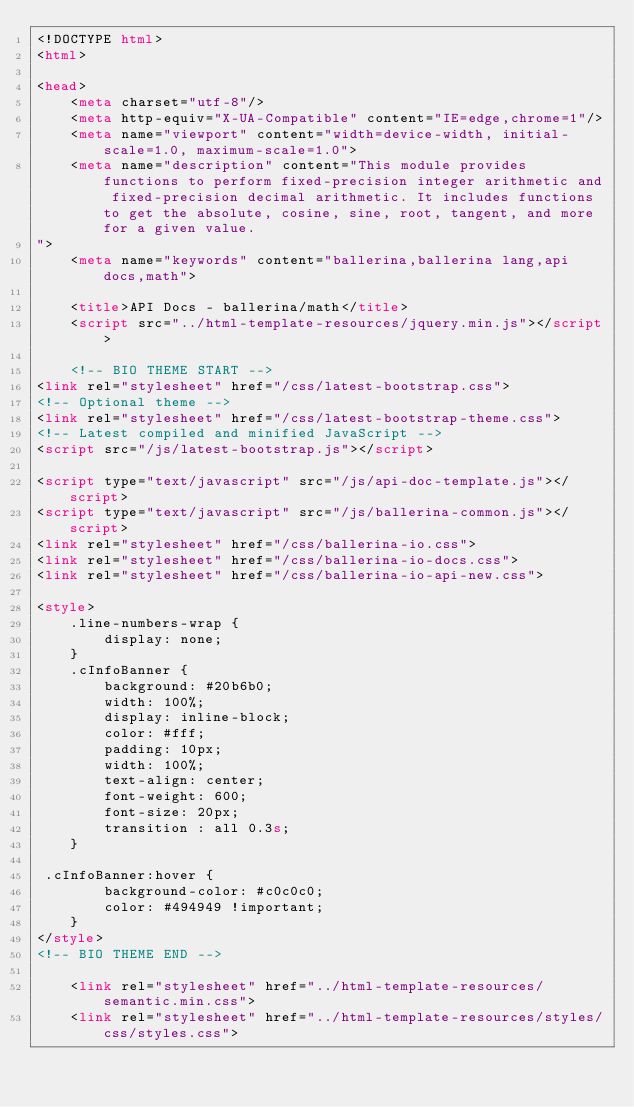<code> <loc_0><loc_0><loc_500><loc_500><_HTML_><!DOCTYPE html>
<html>

<head>
    <meta charset="utf-8"/>
    <meta http-equiv="X-UA-Compatible" content="IE=edge,chrome=1"/>
    <meta name="viewport" content="width=device-width, initial-scale=1.0, maximum-scale=1.0">
    <meta name="description" content="This module provides functions to perform fixed-precision integer arithmetic and fixed-precision decimal arithmetic. It includes functions to get the absolute, cosine, sine, root, tangent, and more for a given value.
">
    <meta name="keywords" content="ballerina,ballerina lang,api docs,math">

    <title>API Docs - ballerina/math</title>
    <script src="../html-template-resources/jquery.min.js"></script>

    <!-- BIO THEME START -->
<link rel="stylesheet" href="/css/latest-bootstrap.css">
<!-- Optional theme -->
<link rel="stylesheet" href="/css/latest-bootstrap-theme.css">
<!-- Latest compiled and minified JavaScript -->
<script src="/js/latest-bootstrap.js"></script>

<script type="text/javascript" src="/js/api-doc-template.js"></script>
<script type="text/javascript" src="/js/ballerina-common.js"></script>
<link rel="stylesheet" href="/css/ballerina-io.css">
<link rel="stylesheet" href="/css/ballerina-io-docs.css">
<link rel="stylesheet" href="/css/ballerina-io-api-new.css">

<style>
    .line-numbers-wrap {
        display: none;
    }
    .cInfoBanner {
        background: #20b6b0;
        width: 100%;
        display: inline-block;
        color: #fff;
        padding: 10px;
        width: 100%;
        text-align: center;
        font-weight: 600;
        font-size: 20px;
        transition : all 0.3s;
    }

 .cInfoBanner:hover {
        background-color: #c0c0c0;
        color: #494949 !important;
    }
</style>
<!-- BIO THEME END -->

    <link rel="stylesheet" href="../html-template-resources/semantic.min.css">
    <link rel="stylesheet" href="../html-template-resources/styles/css/styles.css"></code> 